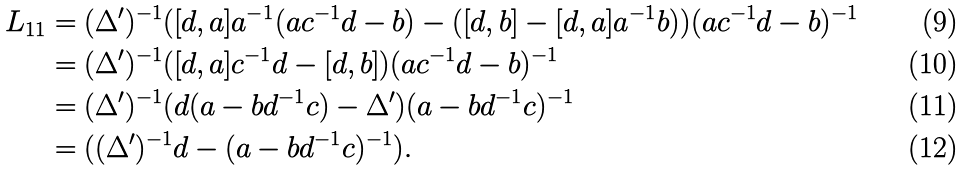<formula> <loc_0><loc_0><loc_500><loc_500>L _ { 1 1 } & = ( \Delta ^ { \prime } ) ^ { - 1 } ( [ d , a ] a ^ { - 1 } ( a c ^ { - 1 } d - b ) - ( [ d , b ] - [ d , a ] a ^ { - 1 } b ) ) ( a c ^ { - 1 } d - b ) ^ { - 1 } \\ & = ( \Delta ^ { \prime } ) ^ { - 1 } ( [ d , a ] c ^ { - 1 } d - [ d , b ] ) ( a c ^ { - 1 } d - b ) ^ { - 1 } \\ & = ( \Delta ^ { \prime } ) ^ { - 1 } ( d ( a - b d ^ { - 1 } c ) - \Delta ^ { \prime } ) ( a - b d ^ { - 1 } c ) ^ { - 1 } \\ & = ( ( \Delta ^ { \prime } ) ^ { - 1 } d - ( a - b d ^ { - 1 } c ) ^ { - 1 } ) .</formula> 